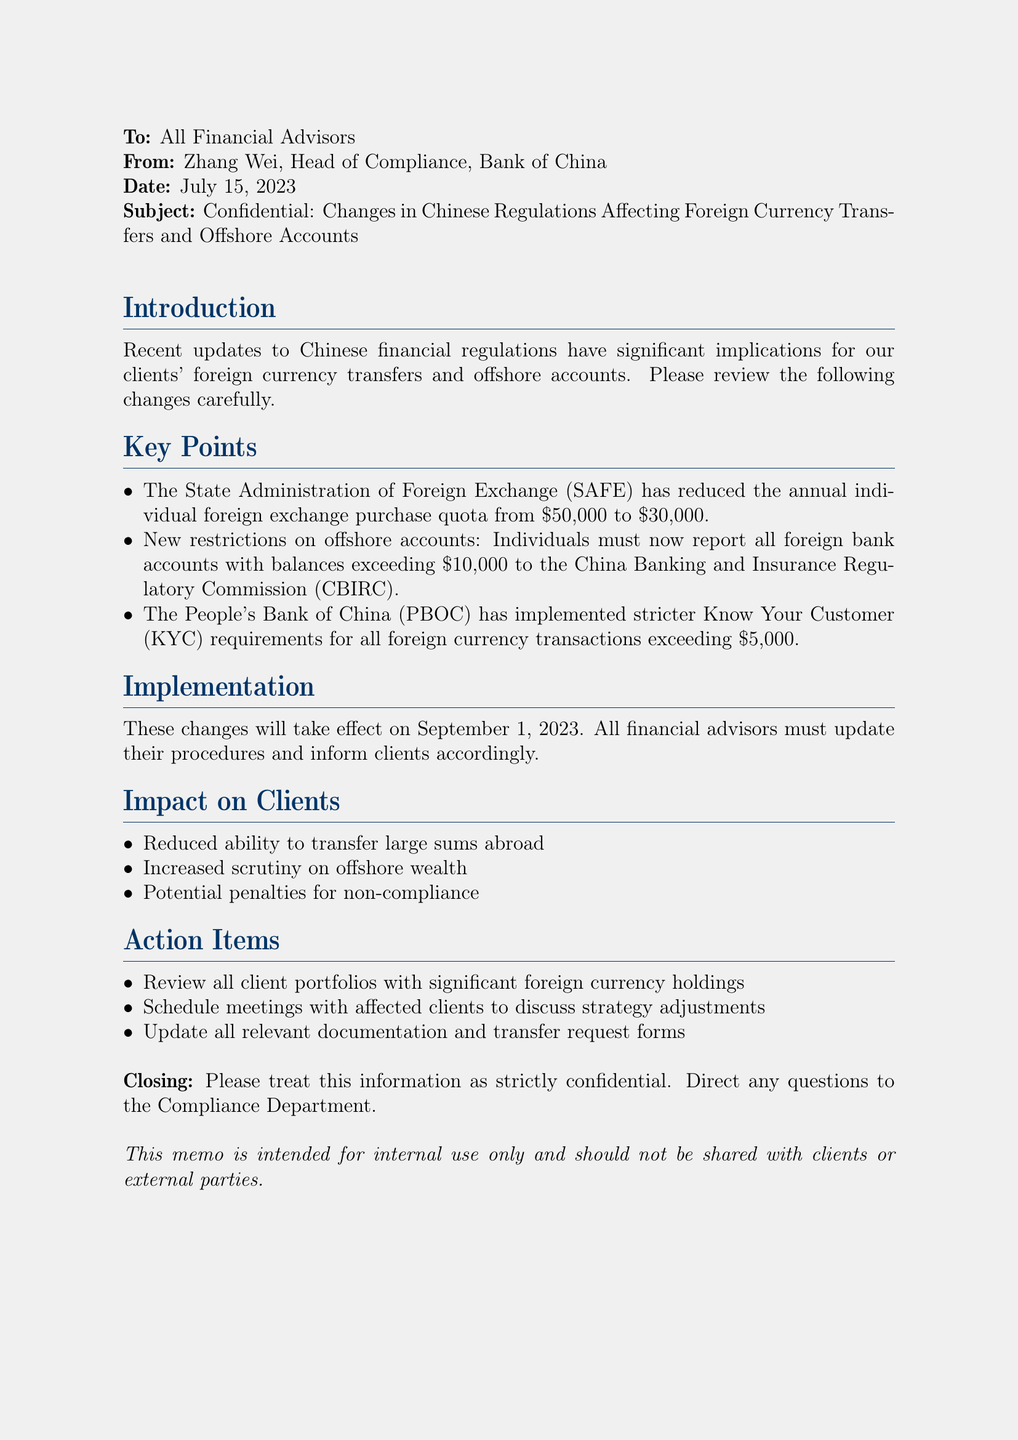What is the date of the memo? The date of the memo is specifically mentioned in the document as July 15, 2023.
Answer: July 15, 2023 Who is the author of the memo? The author of the memo is identified as Zhang Wei, Head of Compliance, Bank of China.
Answer: Zhang Wei What is the new annual individual foreign exchange purchase quota? The document states that the new quota has been reduced to $30,000 from the previous amount.
Answer: $30,000 What is the balance threshold for reporting offshore accounts? The memo outlines that individuals must report foreign bank accounts with balances exceeding $10,000.
Answer: $10,000 When do the new changes take effect? The document indicates that the changes will be effective starting September 1, 2023.
Answer: September 1, 2023 What is the penalty for not complying with the new regulations? The document mentions potential penalties for non-compliance but does not specify the details; thus, it implies the risk involved.
Answer: Potential penalties How many action items are listed in the document? The document provides a list of three action items that financial advisors must follow.
Answer: Three What is the overall tone of the memo regarding the information shared? The memo explicitly states to treat the information as strictly confidential, indicating a serious tone regarding compliance and sensitivity.
Answer: Strictly confidential 